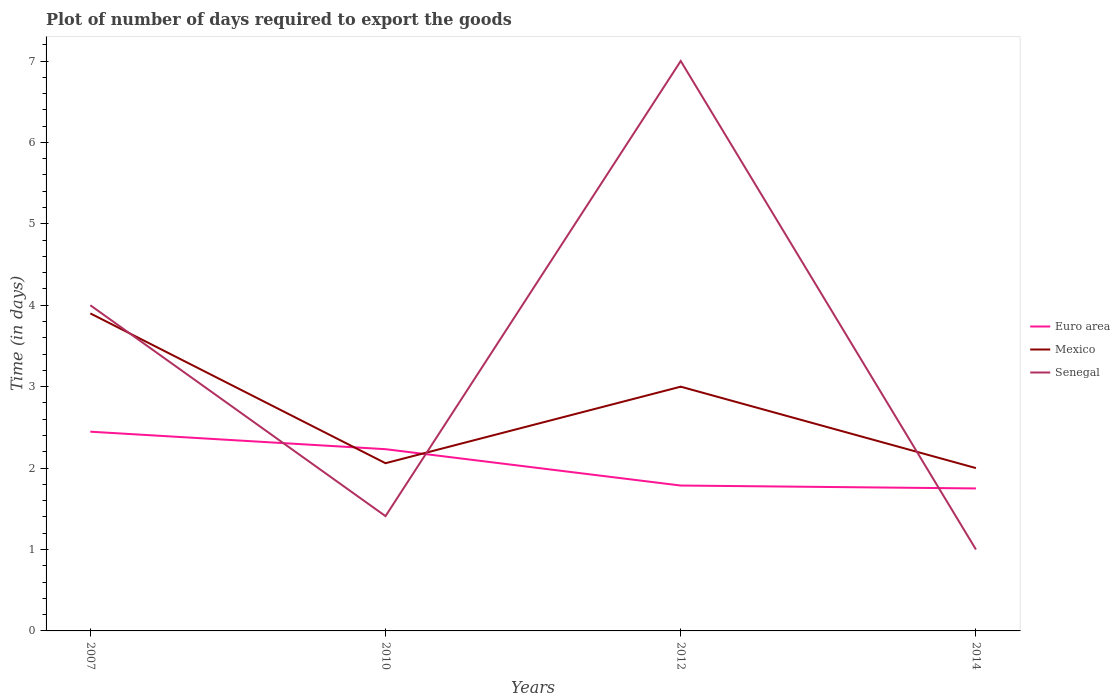How many different coloured lines are there?
Make the answer very short. 3. In which year was the time required to export goods in Euro area maximum?
Offer a very short reply. 2014. What is the total time required to export goods in Euro area in the graph?
Keep it short and to the point. 0.66. What is the difference between the highest and the second highest time required to export goods in Mexico?
Keep it short and to the point. 1.9. Is the time required to export goods in Euro area strictly greater than the time required to export goods in Senegal over the years?
Keep it short and to the point. No. How many years are there in the graph?
Ensure brevity in your answer.  4. What is the difference between two consecutive major ticks on the Y-axis?
Give a very brief answer. 1. Where does the legend appear in the graph?
Ensure brevity in your answer.  Center right. How many legend labels are there?
Keep it short and to the point. 3. How are the legend labels stacked?
Keep it short and to the point. Vertical. What is the title of the graph?
Keep it short and to the point. Plot of number of days required to export the goods. What is the label or title of the X-axis?
Your response must be concise. Years. What is the label or title of the Y-axis?
Your response must be concise. Time (in days). What is the Time (in days) in Euro area in 2007?
Provide a short and direct response. 2.45. What is the Time (in days) in Euro area in 2010?
Make the answer very short. 2.23. What is the Time (in days) of Mexico in 2010?
Provide a short and direct response. 2.06. What is the Time (in days) in Senegal in 2010?
Provide a short and direct response. 1.41. What is the Time (in days) in Euro area in 2012?
Offer a very short reply. 1.79. What is the Time (in days) of Mexico in 2012?
Your answer should be very brief. 3. What is the Time (in days) of Euro area in 2014?
Offer a terse response. 1.75. What is the Time (in days) of Mexico in 2014?
Ensure brevity in your answer.  2. Across all years, what is the maximum Time (in days) of Euro area?
Your response must be concise. 2.45. Across all years, what is the maximum Time (in days) of Mexico?
Provide a short and direct response. 3.9. Across all years, what is the minimum Time (in days) of Euro area?
Give a very brief answer. 1.75. Across all years, what is the minimum Time (in days) in Senegal?
Provide a succinct answer. 1. What is the total Time (in days) in Euro area in the graph?
Give a very brief answer. 8.21. What is the total Time (in days) of Mexico in the graph?
Your answer should be compact. 10.96. What is the total Time (in days) in Senegal in the graph?
Keep it short and to the point. 13.41. What is the difference between the Time (in days) of Euro area in 2007 and that in 2010?
Keep it short and to the point. 0.21. What is the difference between the Time (in days) of Mexico in 2007 and that in 2010?
Keep it short and to the point. 1.84. What is the difference between the Time (in days) of Senegal in 2007 and that in 2010?
Offer a very short reply. 2.59. What is the difference between the Time (in days) of Euro area in 2007 and that in 2012?
Offer a terse response. 0.66. What is the difference between the Time (in days) in Euro area in 2007 and that in 2014?
Give a very brief answer. 0.7. What is the difference between the Time (in days) of Euro area in 2010 and that in 2012?
Offer a terse response. 0.45. What is the difference between the Time (in days) of Mexico in 2010 and that in 2012?
Your response must be concise. -0.94. What is the difference between the Time (in days) in Senegal in 2010 and that in 2012?
Provide a short and direct response. -5.59. What is the difference between the Time (in days) of Euro area in 2010 and that in 2014?
Make the answer very short. 0.48. What is the difference between the Time (in days) of Mexico in 2010 and that in 2014?
Give a very brief answer. 0.06. What is the difference between the Time (in days) of Senegal in 2010 and that in 2014?
Provide a succinct answer. 0.41. What is the difference between the Time (in days) of Euro area in 2012 and that in 2014?
Make the answer very short. 0.04. What is the difference between the Time (in days) of Mexico in 2012 and that in 2014?
Ensure brevity in your answer.  1. What is the difference between the Time (in days) of Euro area in 2007 and the Time (in days) of Mexico in 2010?
Your response must be concise. 0.39. What is the difference between the Time (in days) of Euro area in 2007 and the Time (in days) of Senegal in 2010?
Keep it short and to the point. 1.04. What is the difference between the Time (in days) of Mexico in 2007 and the Time (in days) of Senegal in 2010?
Give a very brief answer. 2.49. What is the difference between the Time (in days) of Euro area in 2007 and the Time (in days) of Mexico in 2012?
Provide a short and direct response. -0.55. What is the difference between the Time (in days) of Euro area in 2007 and the Time (in days) of Senegal in 2012?
Make the answer very short. -4.55. What is the difference between the Time (in days) in Mexico in 2007 and the Time (in days) in Senegal in 2012?
Offer a terse response. -3.1. What is the difference between the Time (in days) of Euro area in 2007 and the Time (in days) of Mexico in 2014?
Keep it short and to the point. 0.45. What is the difference between the Time (in days) of Euro area in 2007 and the Time (in days) of Senegal in 2014?
Make the answer very short. 1.45. What is the difference between the Time (in days) of Mexico in 2007 and the Time (in days) of Senegal in 2014?
Ensure brevity in your answer.  2.9. What is the difference between the Time (in days) in Euro area in 2010 and the Time (in days) in Mexico in 2012?
Your response must be concise. -0.77. What is the difference between the Time (in days) of Euro area in 2010 and the Time (in days) of Senegal in 2012?
Your answer should be compact. -4.77. What is the difference between the Time (in days) of Mexico in 2010 and the Time (in days) of Senegal in 2012?
Your response must be concise. -4.94. What is the difference between the Time (in days) in Euro area in 2010 and the Time (in days) in Mexico in 2014?
Give a very brief answer. 0.23. What is the difference between the Time (in days) of Euro area in 2010 and the Time (in days) of Senegal in 2014?
Your answer should be compact. 1.23. What is the difference between the Time (in days) in Mexico in 2010 and the Time (in days) in Senegal in 2014?
Give a very brief answer. 1.06. What is the difference between the Time (in days) of Euro area in 2012 and the Time (in days) of Mexico in 2014?
Your answer should be very brief. -0.21. What is the difference between the Time (in days) in Euro area in 2012 and the Time (in days) in Senegal in 2014?
Your response must be concise. 0.79. What is the difference between the Time (in days) in Mexico in 2012 and the Time (in days) in Senegal in 2014?
Your answer should be very brief. 2. What is the average Time (in days) of Euro area per year?
Your answer should be compact. 2.05. What is the average Time (in days) in Mexico per year?
Provide a short and direct response. 2.74. What is the average Time (in days) of Senegal per year?
Your answer should be compact. 3.35. In the year 2007, what is the difference between the Time (in days) in Euro area and Time (in days) in Mexico?
Your response must be concise. -1.45. In the year 2007, what is the difference between the Time (in days) in Euro area and Time (in days) in Senegal?
Provide a short and direct response. -1.55. In the year 2007, what is the difference between the Time (in days) of Mexico and Time (in days) of Senegal?
Your answer should be compact. -0.1. In the year 2010, what is the difference between the Time (in days) of Euro area and Time (in days) of Mexico?
Provide a short and direct response. 0.17. In the year 2010, what is the difference between the Time (in days) in Euro area and Time (in days) in Senegal?
Offer a very short reply. 0.82. In the year 2010, what is the difference between the Time (in days) in Mexico and Time (in days) in Senegal?
Your answer should be compact. 0.65. In the year 2012, what is the difference between the Time (in days) of Euro area and Time (in days) of Mexico?
Offer a very short reply. -1.21. In the year 2012, what is the difference between the Time (in days) of Euro area and Time (in days) of Senegal?
Your response must be concise. -5.21. In the year 2014, what is the difference between the Time (in days) in Mexico and Time (in days) in Senegal?
Provide a succinct answer. 1. What is the ratio of the Time (in days) of Euro area in 2007 to that in 2010?
Your answer should be very brief. 1.1. What is the ratio of the Time (in days) of Mexico in 2007 to that in 2010?
Your response must be concise. 1.89. What is the ratio of the Time (in days) of Senegal in 2007 to that in 2010?
Your response must be concise. 2.84. What is the ratio of the Time (in days) of Euro area in 2007 to that in 2012?
Your answer should be compact. 1.37. What is the ratio of the Time (in days) in Senegal in 2007 to that in 2012?
Make the answer very short. 0.57. What is the ratio of the Time (in days) of Euro area in 2007 to that in 2014?
Offer a terse response. 1.4. What is the ratio of the Time (in days) in Mexico in 2007 to that in 2014?
Keep it short and to the point. 1.95. What is the ratio of the Time (in days) in Mexico in 2010 to that in 2012?
Your answer should be compact. 0.69. What is the ratio of the Time (in days) of Senegal in 2010 to that in 2012?
Offer a terse response. 0.2. What is the ratio of the Time (in days) in Euro area in 2010 to that in 2014?
Your response must be concise. 1.28. What is the ratio of the Time (in days) in Mexico in 2010 to that in 2014?
Provide a short and direct response. 1.03. What is the ratio of the Time (in days) in Senegal in 2010 to that in 2014?
Offer a terse response. 1.41. What is the ratio of the Time (in days) of Euro area in 2012 to that in 2014?
Offer a terse response. 1.02. What is the ratio of the Time (in days) of Mexico in 2012 to that in 2014?
Your answer should be very brief. 1.5. What is the ratio of the Time (in days) in Senegal in 2012 to that in 2014?
Provide a succinct answer. 7. What is the difference between the highest and the second highest Time (in days) in Euro area?
Give a very brief answer. 0.21. What is the difference between the highest and the second highest Time (in days) of Mexico?
Provide a succinct answer. 0.9. What is the difference between the highest and the second highest Time (in days) of Senegal?
Provide a succinct answer. 3. What is the difference between the highest and the lowest Time (in days) of Euro area?
Provide a succinct answer. 0.7. What is the difference between the highest and the lowest Time (in days) in Senegal?
Ensure brevity in your answer.  6. 